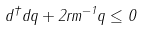Convert formula to latex. <formula><loc_0><loc_0><loc_500><loc_500>d ^ { \dag } d q + 2 r m ^ { - 1 } q \leq 0</formula> 